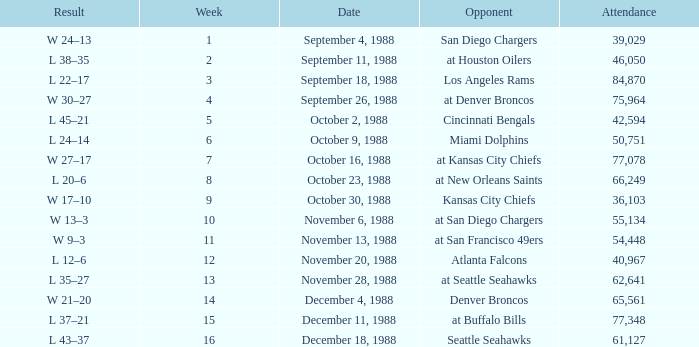What was the date during week 13? November 28, 1988. Parse the table in full. {'header': ['Result', 'Week', 'Date', 'Opponent', 'Attendance'], 'rows': [['W 24–13', '1', 'September 4, 1988', 'San Diego Chargers', '39,029'], ['L 38–35', '2', 'September 11, 1988', 'at Houston Oilers', '46,050'], ['L 22–17', '3', 'September 18, 1988', 'Los Angeles Rams', '84,870'], ['W 30–27', '4', 'September 26, 1988', 'at Denver Broncos', '75,964'], ['L 45–21', '5', 'October 2, 1988', 'Cincinnati Bengals', '42,594'], ['L 24–14', '6', 'October 9, 1988', 'Miami Dolphins', '50,751'], ['W 27–17', '7', 'October 16, 1988', 'at Kansas City Chiefs', '77,078'], ['L 20–6', '8', 'October 23, 1988', 'at New Orleans Saints', '66,249'], ['W 17–10', '9', 'October 30, 1988', 'Kansas City Chiefs', '36,103'], ['W 13–3', '10', 'November 6, 1988', 'at San Diego Chargers', '55,134'], ['W 9–3', '11', 'November 13, 1988', 'at San Francisco 49ers', '54,448'], ['L 12–6', '12', 'November 20, 1988', 'Atlanta Falcons', '40,967'], ['L 35–27', '13', 'November 28, 1988', 'at Seattle Seahawks', '62,641'], ['W 21–20', '14', 'December 4, 1988', 'Denver Broncos', '65,561'], ['L 37–21', '15', 'December 11, 1988', 'at Buffalo Bills', '77,348'], ['L 43–37', '16', 'December 18, 1988', 'Seattle Seahawks', '61,127']]} 